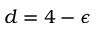Convert formula to latex. <formula><loc_0><loc_0><loc_500><loc_500>d = 4 - \epsilon</formula> 